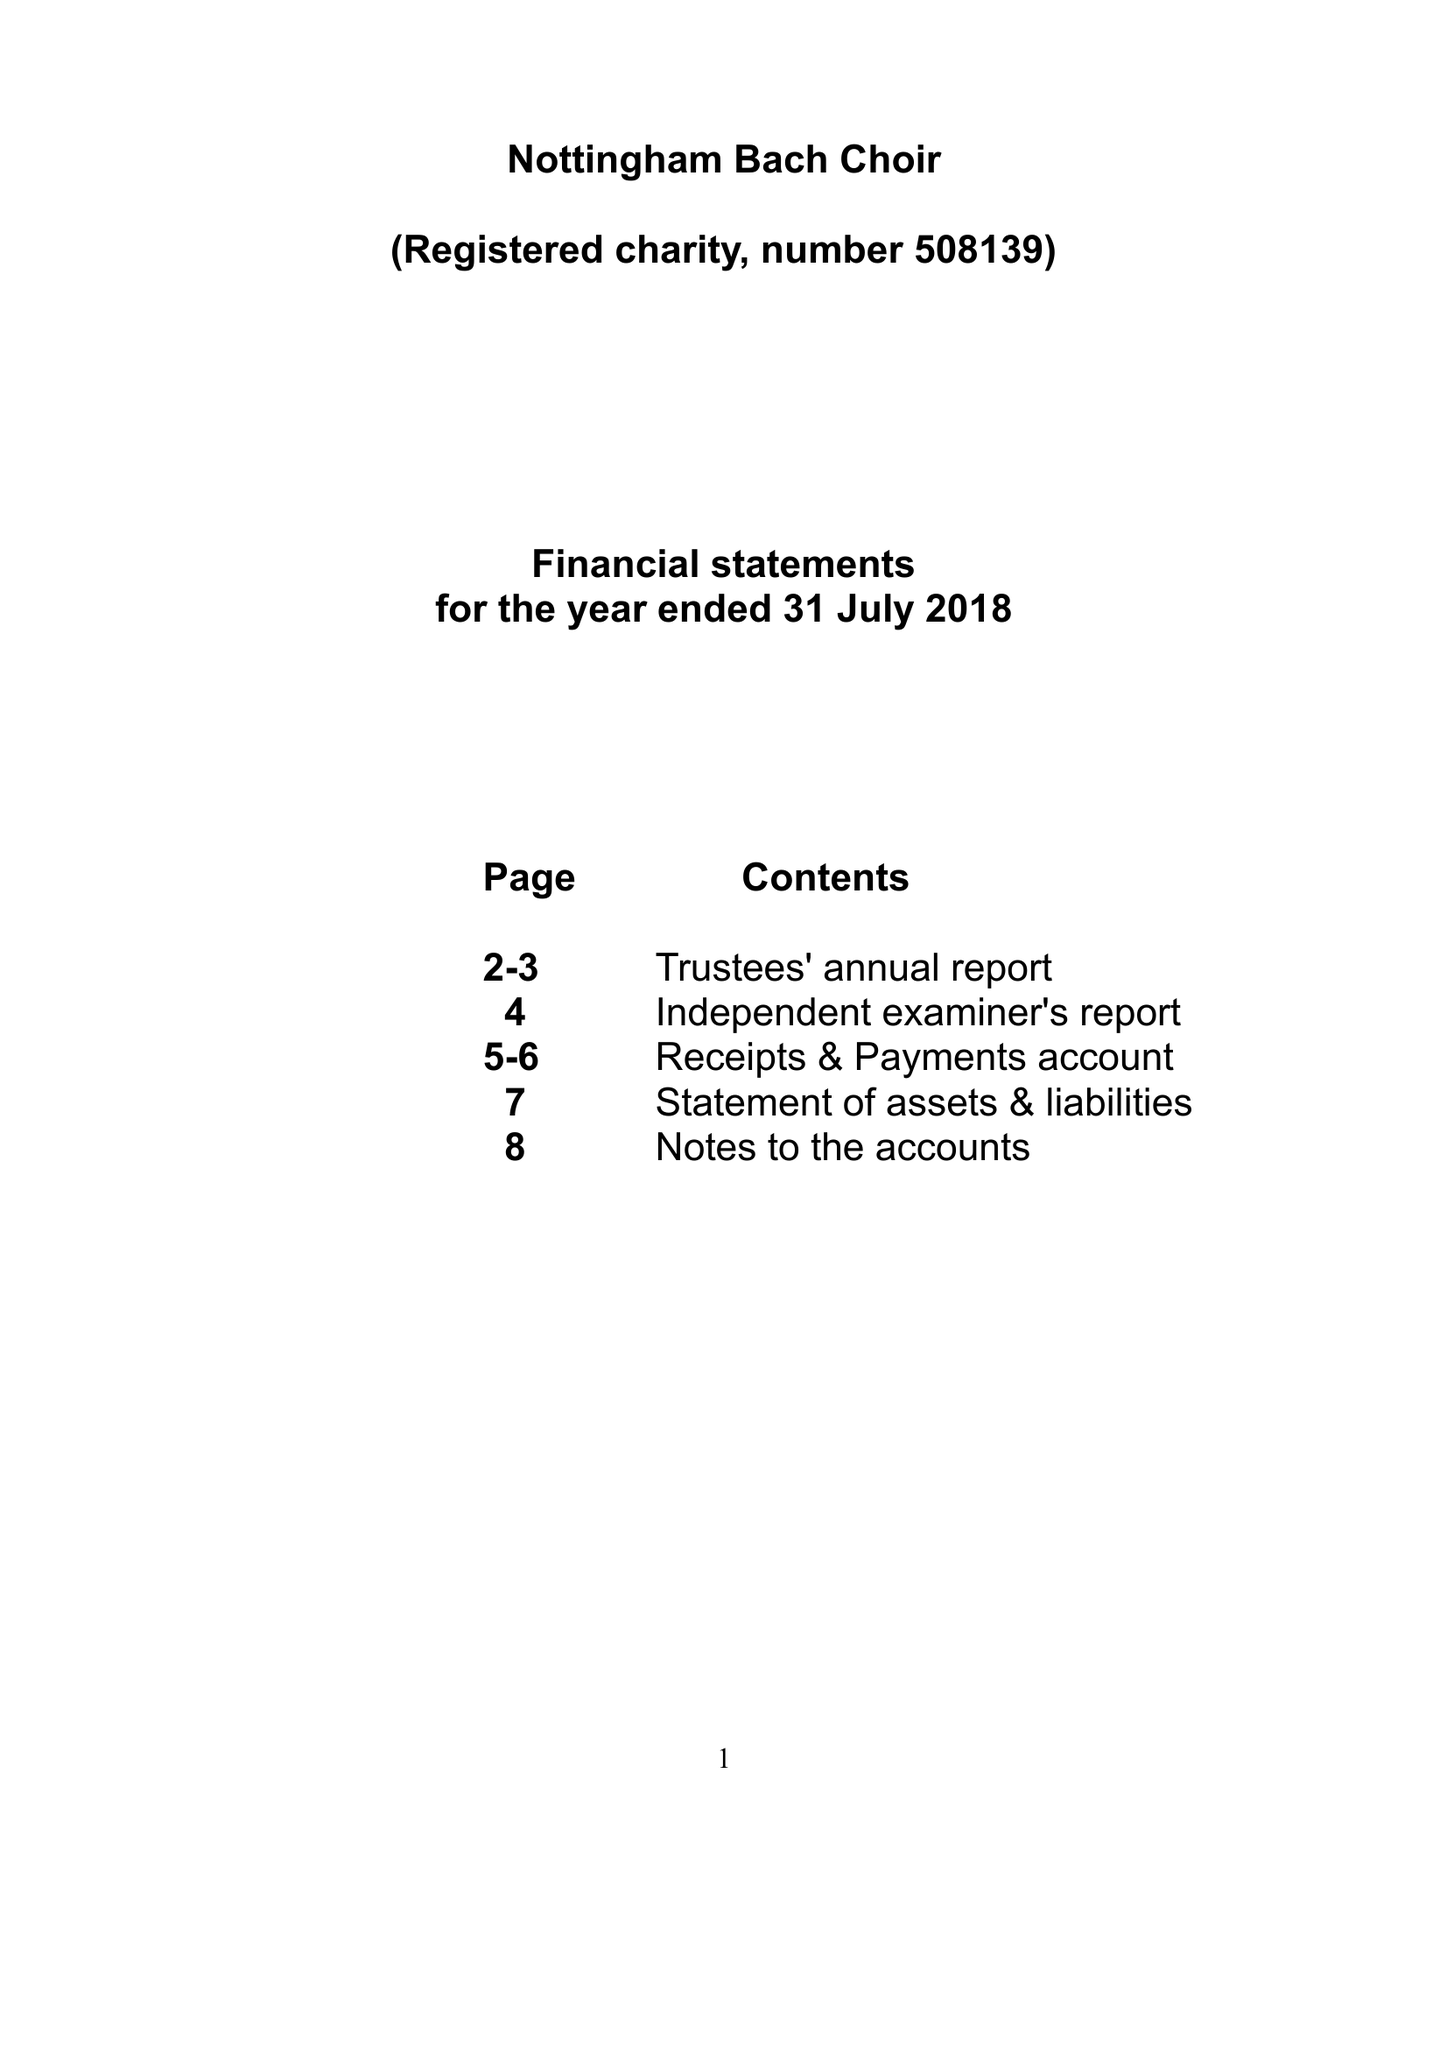What is the value for the address__post_town?
Answer the question using a single word or phrase. LINCOLN 